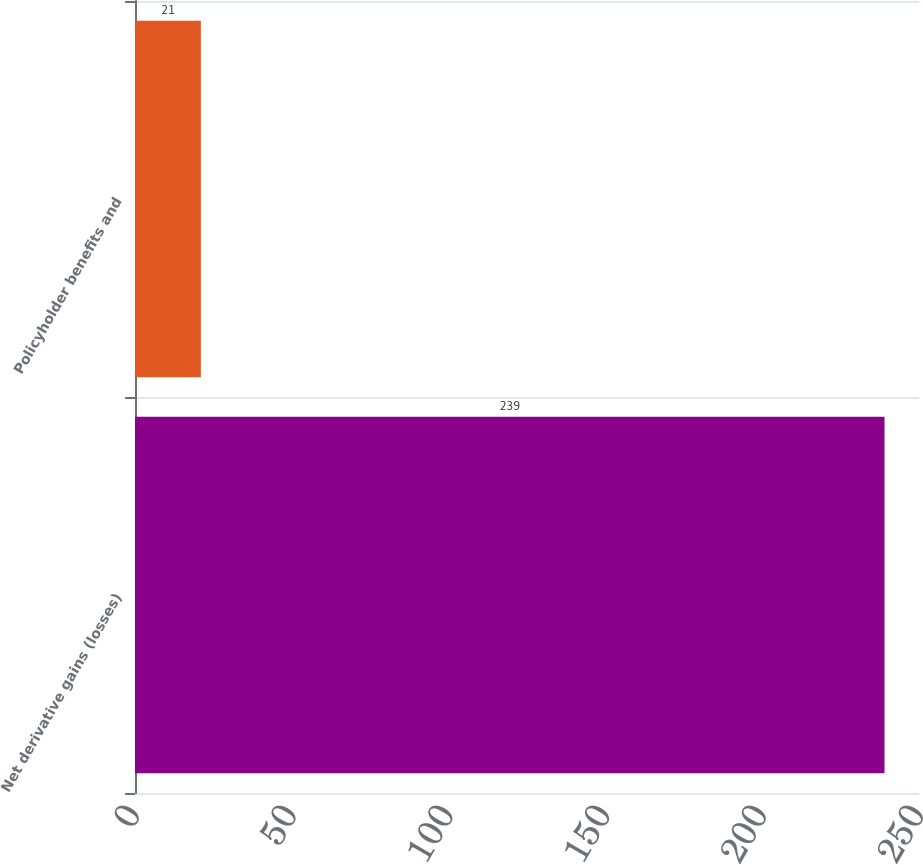Convert chart. <chart><loc_0><loc_0><loc_500><loc_500><bar_chart><fcel>Net derivative gains (losses)<fcel>Policyholder benefits and<nl><fcel>239<fcel>21<nl></chart> 